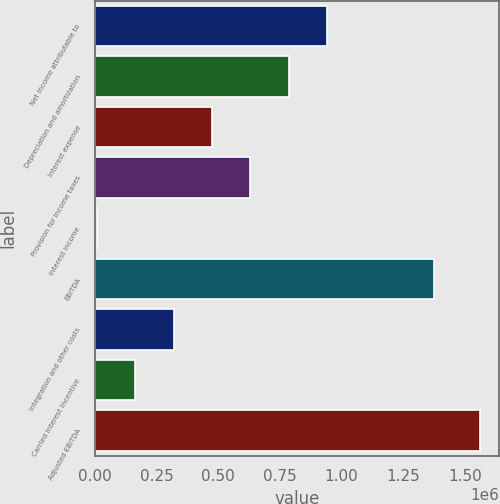Convert chart to OTSL. <chart><loc_0><loc_0><loc_500><loc_500><bar_chart><fcel>Net income attributable to<fcel>Depreciation and amortization<fcel>Interest expense<fcel>Provision for income taxes<fcel>Interest income<fcel>EBITDA<fcel>Integration and other costs<fcel>Carried interest incentive<fcel>Adjusted EBITDA<nl><fcel>940629<fcel>785199<fcel>474340<fcel>629769<fcel>8051<fcel>1.37371e+06<fcel>318910<fcel>163481<fcel>1.56235e+06<nl></chart> 